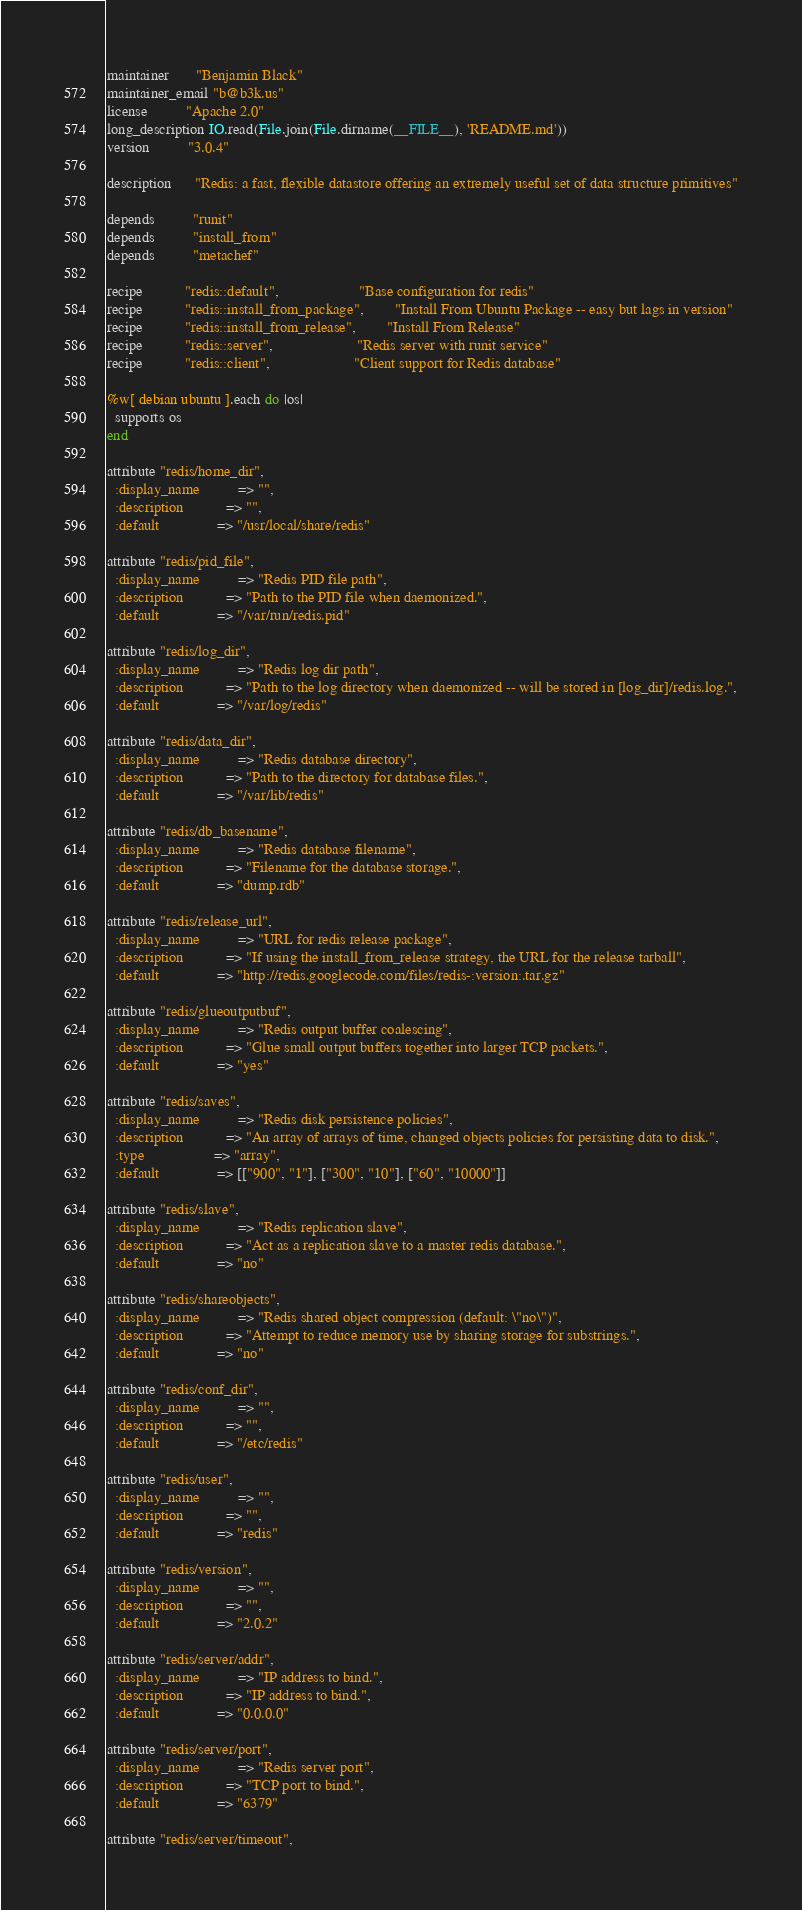<code> <loc_0><loc_0><loc_500><loc_500><_Ruby_>maintainer       "Benjamin Black"
maintainer_email "b@b3k.us"
license          "Apache 2.0"
long_description IO.read(File.join(File.dirname(__FILE__), 'README.md'))
version          "3.0.4"

description      "Redis: a fast, flexible datastore offering an extremely useful set of data structure primitives"

depends          "runit"
depends          "install_from"
depends          "metachef"

recipe           "redis::default",                     "Base configuration for redis"
recipe           "redis::install_from_package",        "Install From Ubuntu Package -- easy but lags in version"
recipe           "redis::install_from_release",        "Install From Release"
recipe           "redis::server",                      "Redis server with runit service"
recipe           "redis::client",                      "Client support for Redis database"

%w[ debian ubuntu ].each do |os|
  supports os
end

attribute "redis/home_dir",
  :display_name          => "",
  :description           => "",
  :default               => "/usr/local/share/redis"

attribute "redis/pid_file",
  :display_name          => "Redis PID file path",
  :description           => "Path to the PID file when daemonized.",
  :default               => "/var/run/redis.pid"

attribute "redis/log_dir",
  :display_name          => "Redis log dir path",
  :description           => "Path to the log directory when daemonized -- will be stored in [log_dir]/redis.log.",
  :default               => "/var/log/redis"

attribute "redis/data_dir",
  :display_name          => "Redis database directory",
  :description           => "Path to the directory for database files.",
  :default               => "/var/lib/redis"

attribute "redis/db_basename",
  :display_name          => "Redis database filename",
  :description           => "Filename for the database storage.",
  :default               => "dump.rdb"

attribute "redis/release_url",
  :display_name          => "URL for redis release package",
  :description           => "If using the install_from_release strategy, the URL for the release tarball",
  :default               => "http://redis.googlecode.com/files/redis-:version:.tar.gz"

attribute "redis/glueoutputbuf",
  :display_name          => "Redis output buffer coalescing",
  :description           => "Glue small output buffers together into larger TCP packets.",
  :default               => "yes"

attribute "redis/saves",
  :display_name          => "Redis disk persistence policies",
  :description           => "An array of arrays of time, changed objects policies for persisting data to disk.",
  :type                  => "array",
  :default               => [["900", "1"], ["300", "10"], ["60", "10000"]]

attribute "redis/slave",
  :display_name          => "Redis replication slave",
  :description           => "Act as a replication slave to a master redis database.",
  :default               => "no"

attribute "redis/shareobjects",
  :display_name          => "Redis shared object compression (default: \"no\")",
  :description           => "Attempt to reduce memory use by sharing storage for substrings.",
  :default               => "no"

attribute "redis/conf_dir",
  :display_name          => "",
  :description           => "",
  :default               => "/etc/redis"

attribute "redis/user",
  :display_name          => "",
  :description           => "",
  :default               => "redis"

attribute "redis/version",
  :display_name          => "",
  :description           => "",
  :default               => "2.0.2"

attribute "redis/server/addr",
  :display_name          => "IP address to bind.",
  :description           => "IP address to bind.",
  :default               => "0.0.0.0"

attribute "redis/server/port",
  :display_name          => "Redis server port",
  :description           => "TCP port to bind.",
  :default               => "6379"

attribute "redis/server/timeout",</code> 